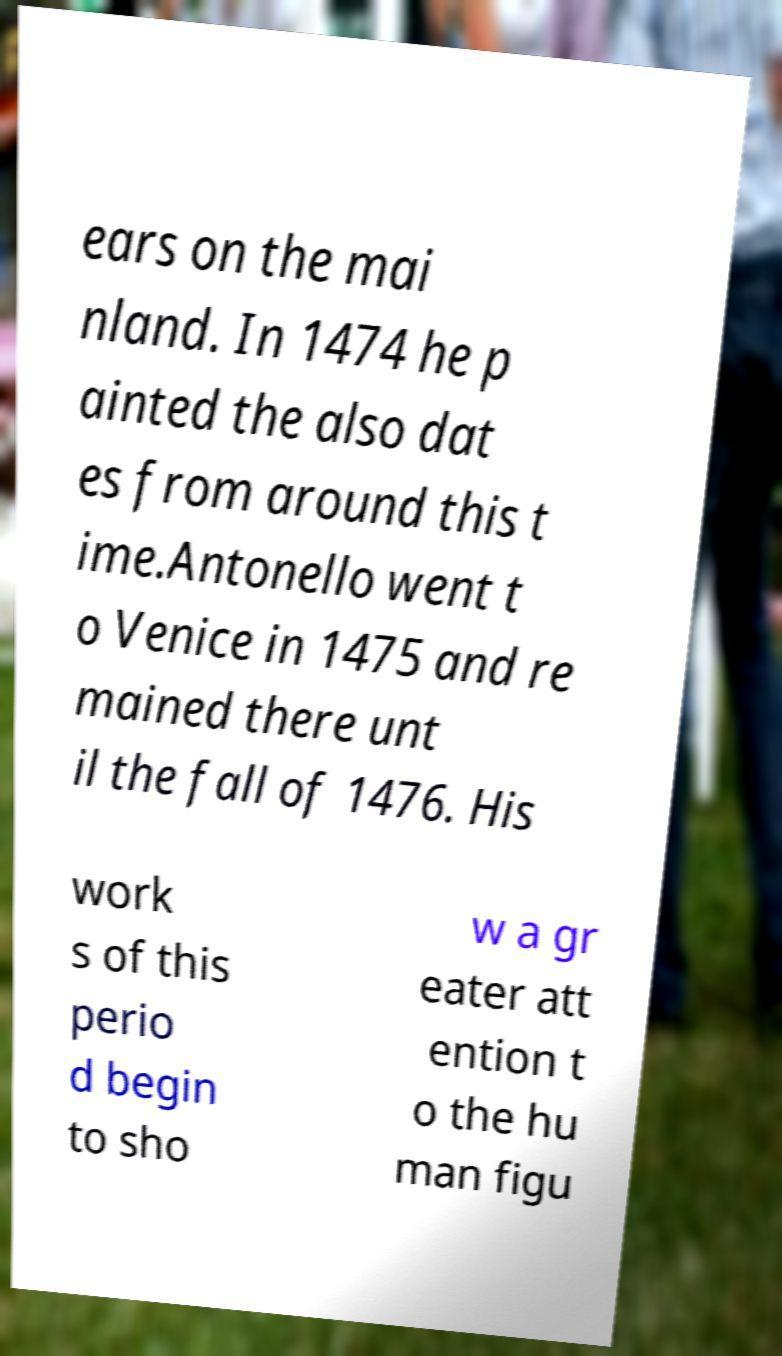Could you assist in decoding the text presented in this image and type it out clearly? ears on the mai nland. In 1474 he p ainted the also dat es from around this t ime.Antonello went t o Venice in 1475 and re mained there unt il the fall of 1476. His work s of this perio d begin to sho w a gr eater att ention t o the hu man figu 